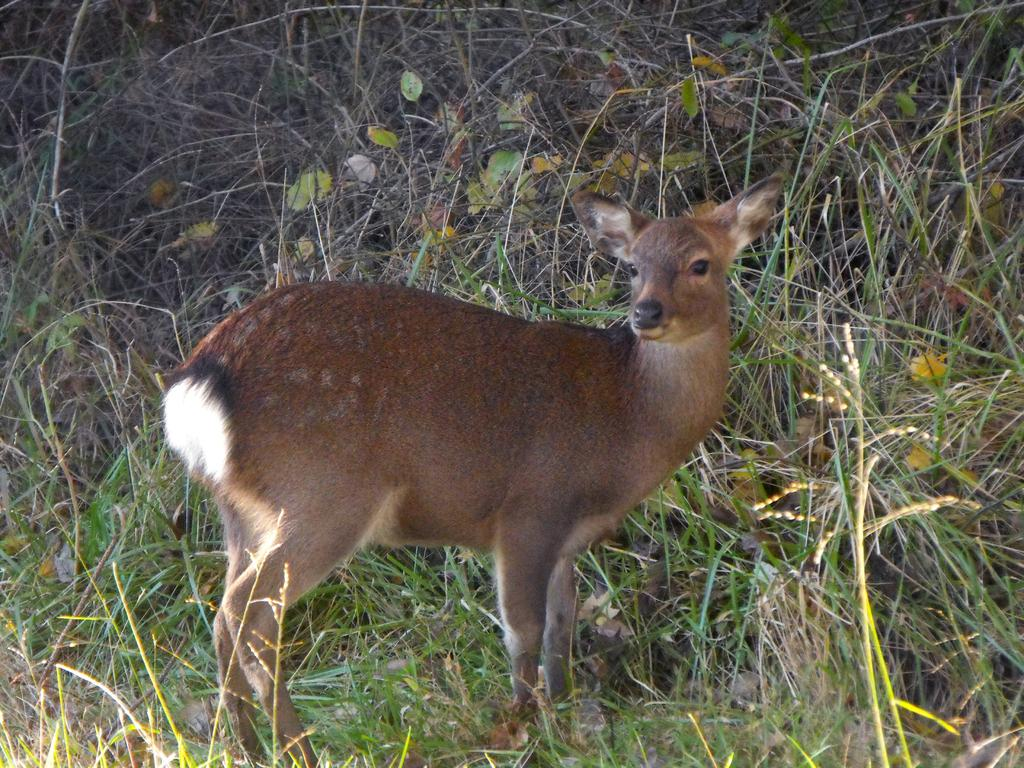What type of animal is in the image? There is a deer in the image. What type of vegetation is present in the image? There is grass and leaves in the image. What color is the crayon on the floor in the image? There is no crayon or floor present in the image; it features a deer in a natural setting with grass and leaves. 